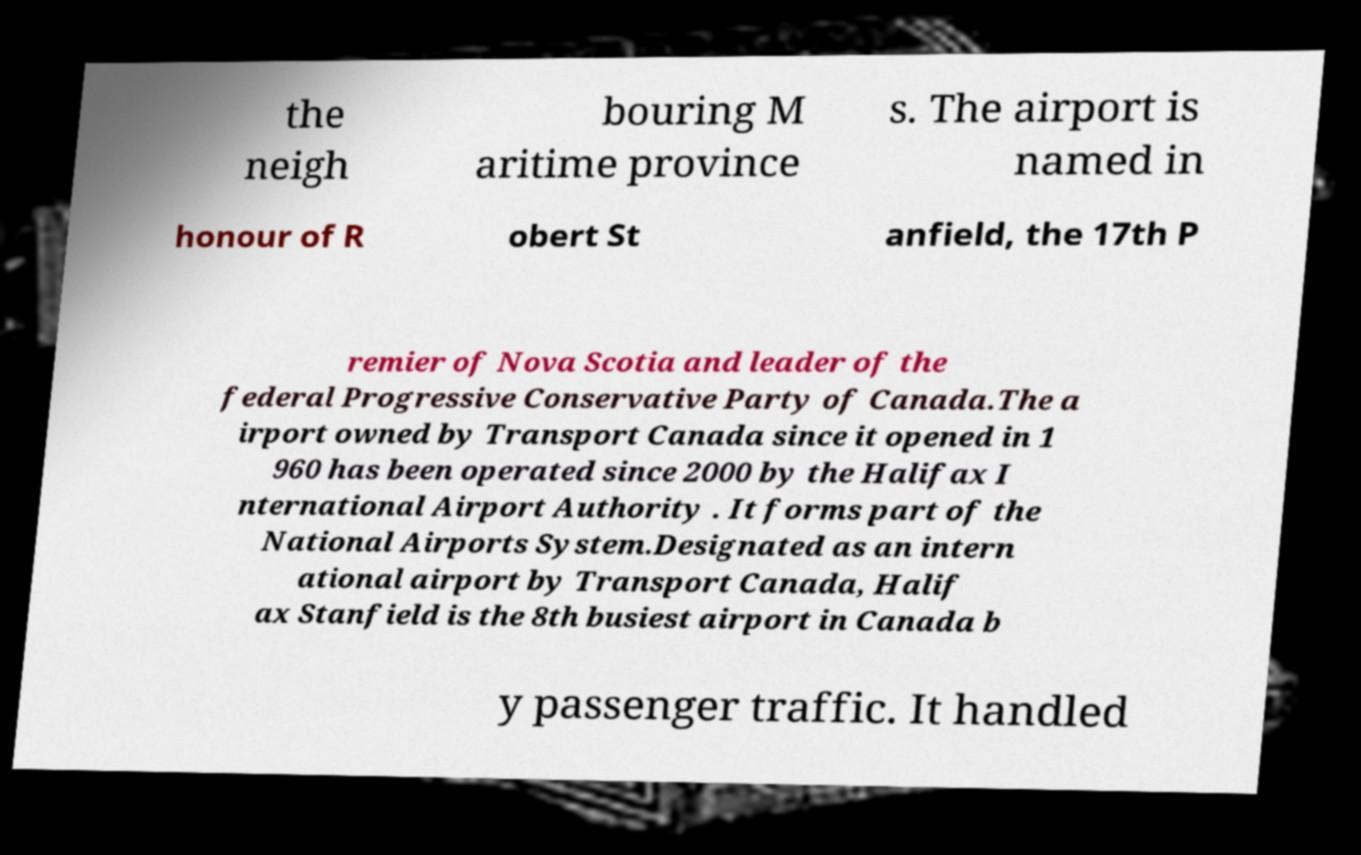I need the written content from this picture converted into text. Can you do that? the neigh bouring M aritime province s. The airport is named in honour of R obert St anfield, the 17th P remier of Nova Scotia and leader of the federal Progressive Conservative Party of Canada.The a irport owned by Transport Canada since it opened in 1 960 has been operated since 2000 by the Halifax I nternational Airport Authority . It forms part of the National Airports System.Designated as an intern ational airport by Transport Canada, Halif ax Stanfield is the 8th busiest airport in Canada b y passenger traffic. It handled 